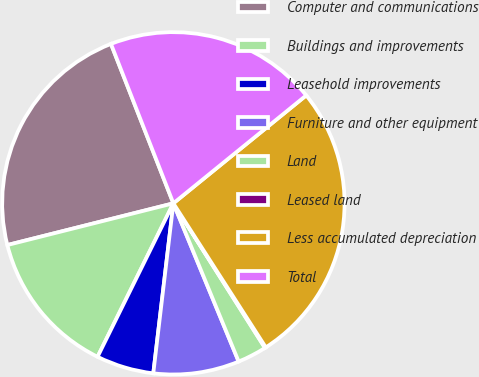Convert chart to OTSL. <chart><loc_0><loc_0><loc_500><loc_500><pie_chart><fcel>Computer and communications<fcel>Buildings and improvements<fcel>Leasehold improvements<fcel>Furniture and other equipment<fcel>Land<fcel>Leased land<fcel>Less accumulated depreciation<fcel>Total<nl><fcel>22.98%<fcel>13.78%<fcel>5.43%<fcel>8.1%<fcel>2.76%<fcel>0.09%<fcel>26.78%<fcel>20.08%<nl></chart> 